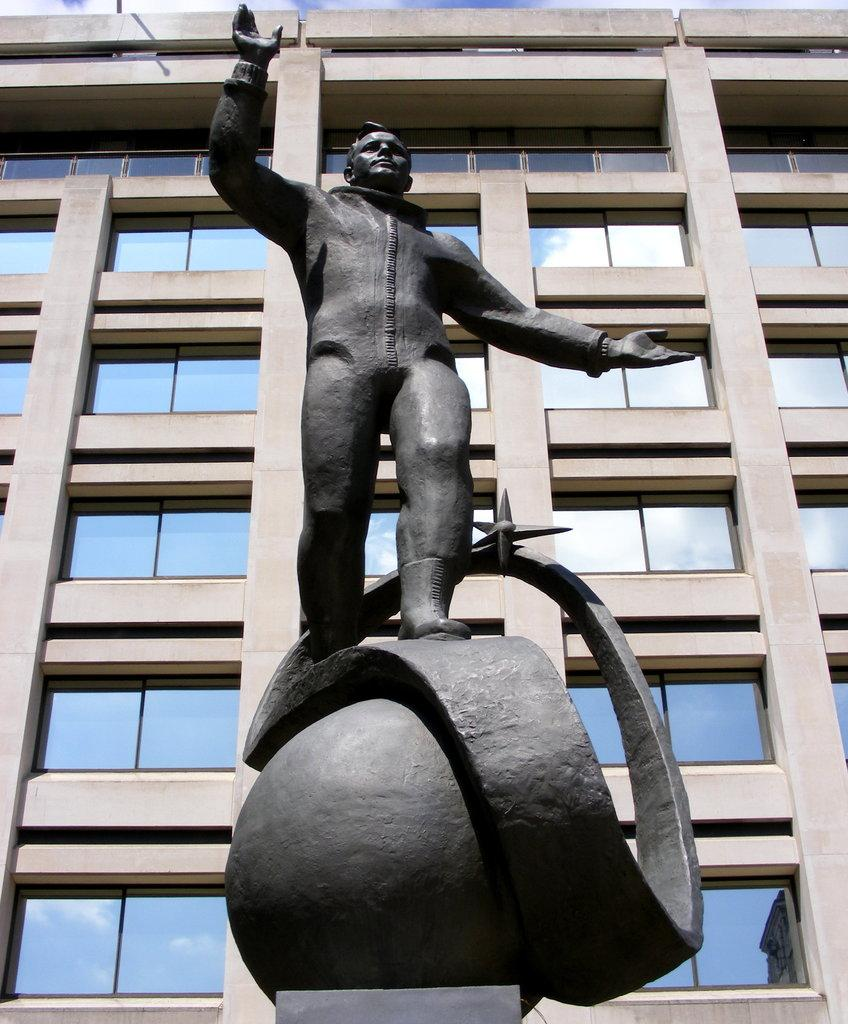What is the main subject in the image? There is a sculpture in the image. What can be seen behind the sculpture? There is a building behind the sculpture. What type of windows does the building have? The building has glass windows. What is visible at the top of the image? The sky is visible at the top of the image. What type of copper sheet is used to create the sculpture in the image? There is no mention of copper or a sheet being used to create the sculpture in the image. 